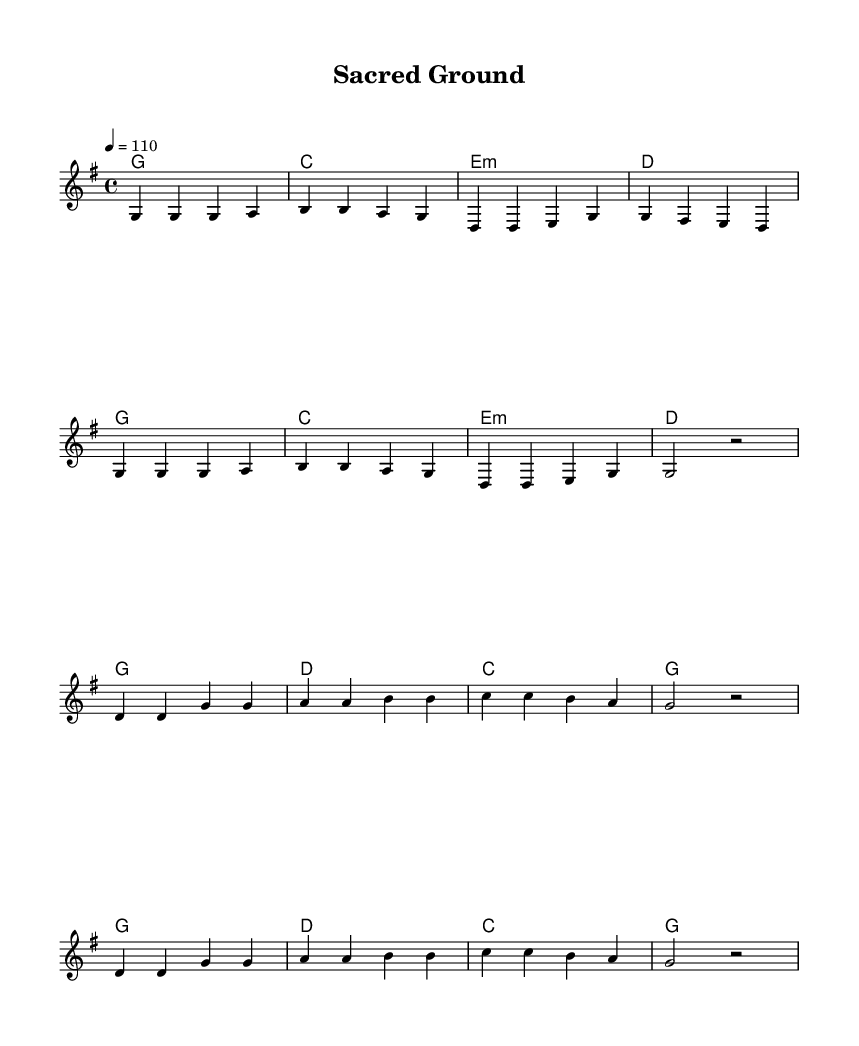What is the key signature of this music? The key signature is G major, which has one sharp (F#). This can be identified by looking at the key signature at the beginning of the staff where one sharp is indicated.
Answer: G major What is the time signature of this music? The time signature is 4/4, which means there are four beats in each measure and a quarter note receives one beat. This is indicated at the beginning of the piece.
Answer: 4/4 What is the tempo marking for this song? The tempo marking is quarter note equals 110, which shows the speed at which the piece should be played. This information is found in the tempo directive at the beginning of the score.
Answer: 110 How many measures are in the verse section? The verse section has eight measures, as indicated by counting each grouping of notes before the repeats and rests in the notation.
Answer: Eight What do the lyrics in the chorus emphasize about the land? The lyrics in the chorus emphasize the need to protect the sacred land and honor the past. This can be understood by reading the words provided alongside the musical notation in the chorus section.
Answer: Protect and honor What is the structure of the song? The structure consists of verses followed by a chorus, repeating both sections. This can be inferred from the musical division: verses lead into choruses and repeat throughout the piece.
Answer: Verse, Chorus, Verse, Chorus What mood does the music evoke based on the lyrics? The music evokes a solemn and respectful mood towards sacred land, which is reflected in the lyrics’ warning and call for protection. The melody and lyrics work together to create an atmosphere of reverence.
Answer: Solemn and respectful 